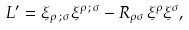Convert formula to latex. <formula><loc_0><loc_0><loc_500><loc_500>L ^ { \prime } = \xi _ { \rho \, ; \, \sigma } \xi ^ { \rho \, ; \, \sigma } - R _ { \rho \sigma } \, \xi ^ { \rho } \xi ^ { \sigma } ,</formula> 